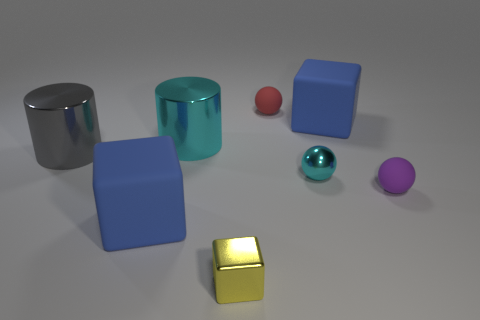Add 1 gray things. How many objects exist? 9 Subtract all blocks. How many objects are left? 5 Add 6 large gray metal cylinders. How many large gray metal cylinders exist? 7 Subtract 0 purple cylinders. How many objects are left? 8 Subtract all large cyan objects. Subtract all small cyan shiny spheres. How many objects are left? 6 Add 3 tiny cyan spheres. How many tiny cyan spheres are left? 4 